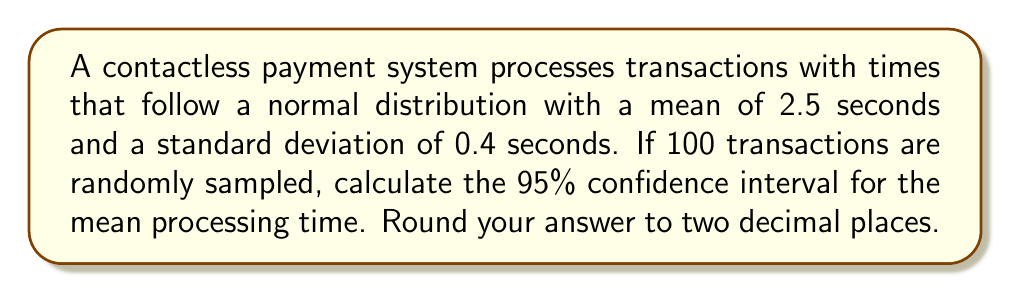Help me with this question. To calculate the confidence interval, we'll follow these steps:

1) The formula for a confidence interval is:

   $$\bar{x} \pm z_{\alpha/2} \cdot \frac{\sigma}{\sqrt{n}}$$

   where:
   $\bar{x}$ is the sample mean (which equals the population mean in this case)
   $z_{\alpha/2}$ is the z-score for the desired confidence level
   $\sigma$ is the population standard deviation
   $n$ is the sample size

2) We know:
   $\bar{x} = 2.5$ seconds
   $\sigma = 0.4$ seconds
   $n = 100$
   For a 95% confidence interval, $z_{\alpha/2} = 1.96$

3) Plugging these values into the formula:

   $$2.5 \pm 1.96 \cdot \frac{0.4}{\sqrt{100}}$$

4) Simplify:
   $$2.5 \pm 1.96 \cdot \frac{0.4}{10}$$
   $$2.5 \pm 1.96 \cdot 0.04$$
   $$2.5 \pm 0.0784$$

5) Calculate the interval:
   Lower bound: $2.5 - 0.0784 = 2.4216$
   Upper bound: $2.5 + 0.0784 = 2.5784$

6) Rounding to two decimal places:
   Lower bound: 2.42
   Upper bound: 2.58
Answer: (2.42, 2.58) 